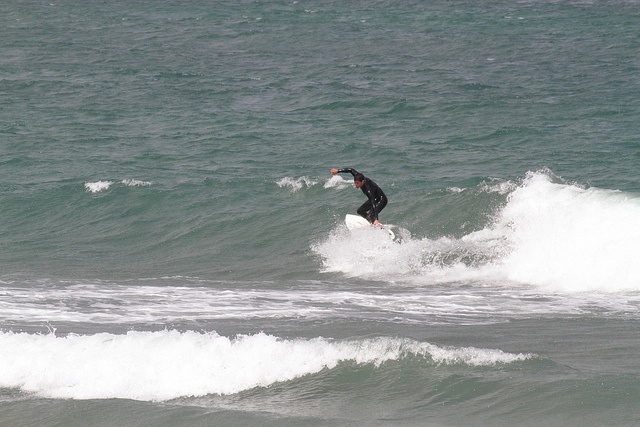Describe the objects in this image and their specific colors. I can see people in gray, black, maroon, and lightpink tones and surfboard in gray, white, and darkgray tones in this image. 